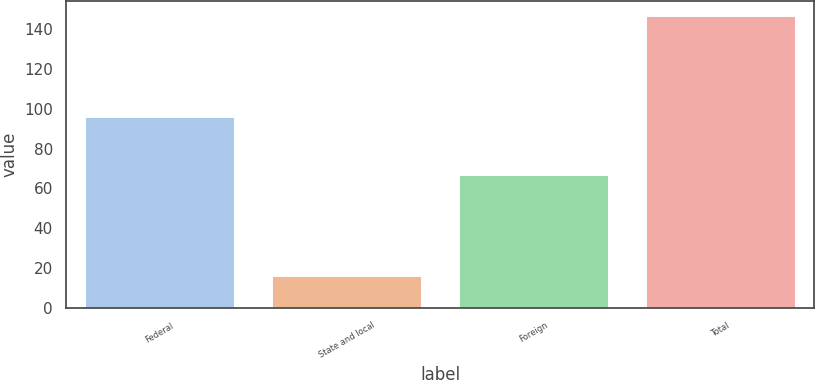Convert chart. <chart><loc_0><loc_0><loc_500><loc_500><bar_chart><fcel>Federal<fcel>State and local<fcel>Foreign<fcel>Total<nl><fcel>96<fcel>16<fcel>67<fcel>147<nl></chart> 